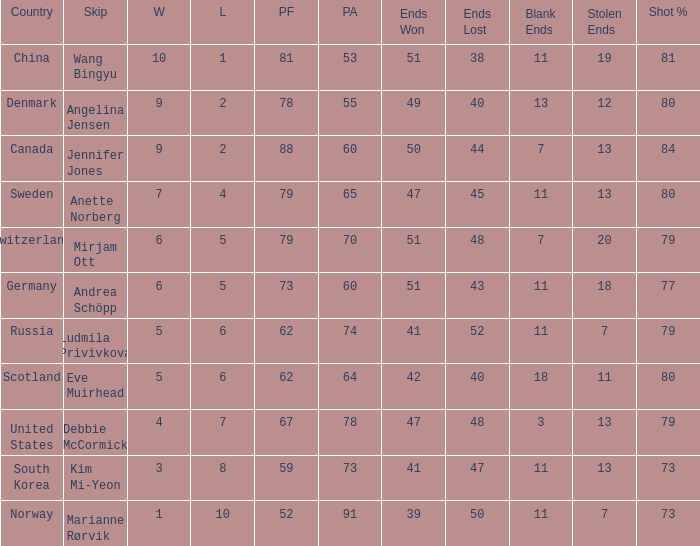What is Norway's least ends lost? 50.0. 